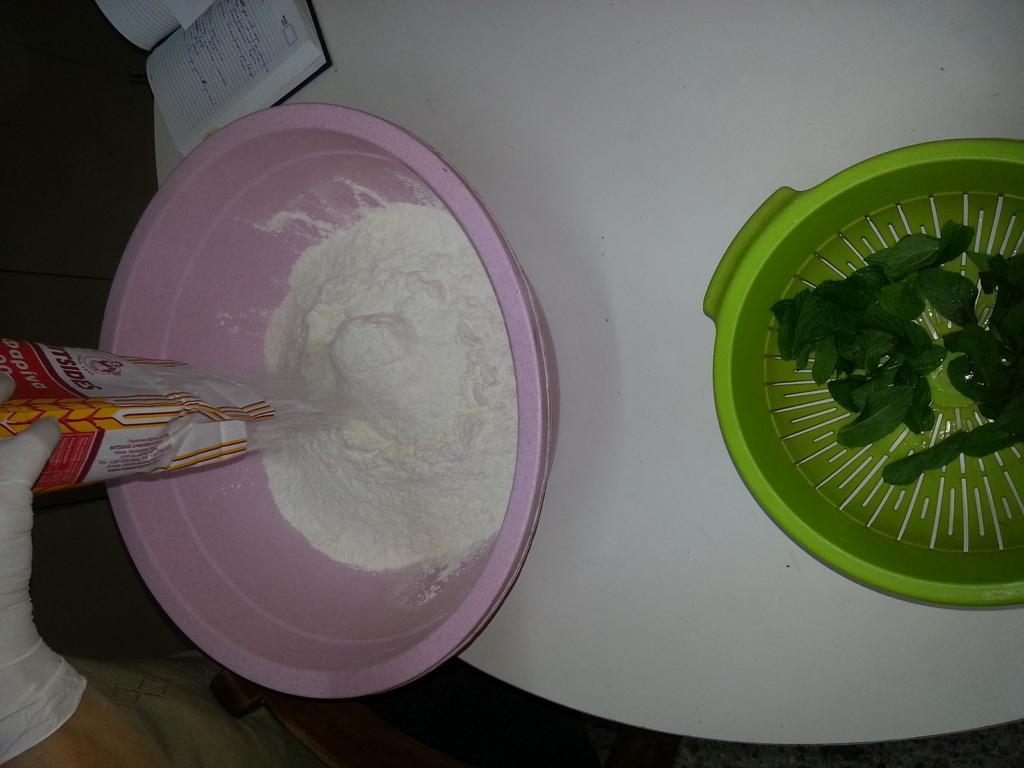Could you give a brief overview of what you see in this image? On the left side, there is a person wearing a white color glove, pouring a white color powder in a pink color bowl which is on the white color table. On which, there is a green colored box in which, there are levels and there is a book. And the background is dark in color. 